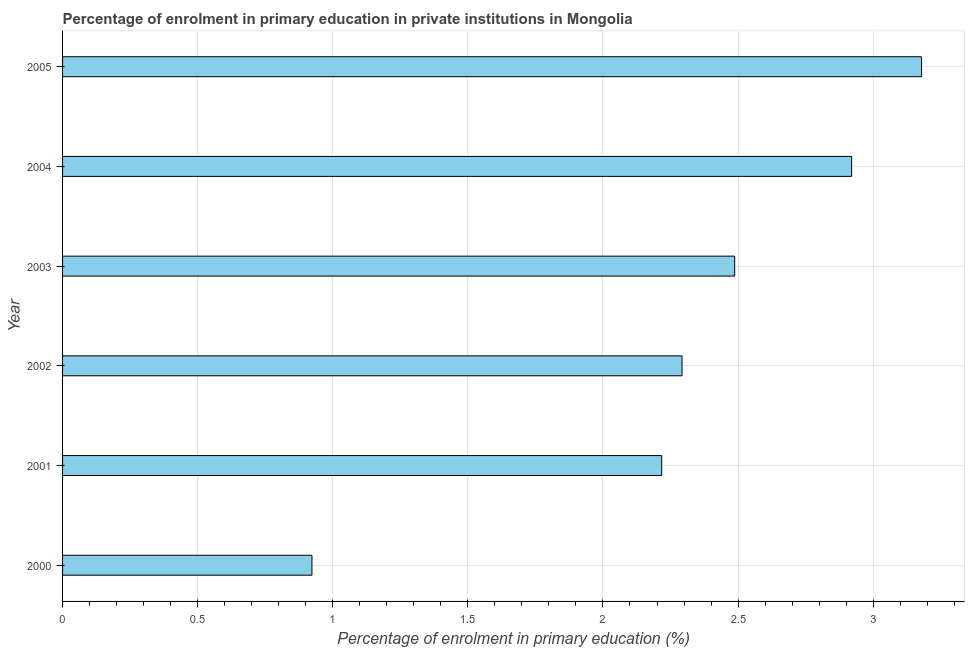Does the graph contain grids?
Offer a very short reply. Yes. What is the title of the graph?
Offer a very short reply. Percentage of enrolment in primary education in private institutions in Mongolia. What is the label or title of the X-axis?
Ensure brevity in your answer.  Percentage of enrolment in primary education (%). What is the enrolment percentage in primary education in 2003?
Provide a short and direct response. 2.49. Across all years, what is the maximum enrolment percentage in primary education?
Your response must be concise. 3.18. Across all years, what is the minimum enrolment percentage in primary education?
Ensure brevity in your answer.  0.92. In which year was the enrolment percentage in primary education maximum?
Offer a terse response. 2005. In which year was the enrolment percentage in primary education minimum?
Provide a succinct answer. 2000. What is the sum of the enrolment percentage in primary education?
Ensure brevity in your answer.  14.02. What is the difference between the enrolment percentage in primary education in 2001 and 2003?
Provide a succinct answer. -0.27. What is the average enrolment percentage in primary education per year?
Provide a short and direct response. 2.34. What is the median enrolment percentage in primary education?
Provide a succinct answer. 2.39. In how many years, is the enrolment percentage in primary education greater than 2.8 %?
Provide a short and direct response. 2. What is the ratio of the enrolment percentage in primary education in 2004 to that in 2005?
Offer a very short reply. 0.92. Is the enrolment percentage in primary education in 2000 less than that in 2003?
Provide a succinct answer. Yes. Is the difference between the enrolment percentage in primary education in 2000 and 2001 greater than the difference between any two years?
Make the answer very short. No. What is the difference between the highest and the second highest enrolment percentage in primary education?
Your answer should be very brief. 0.26. What is the difference between the highest and the lowest enrolment percentage in primary education?
Your answer should be compact. 2.26. In how many years, is the enrolment percentage in primary education greater than the average enrolment percentage in primary education taken over all years?
Keep it short and to the point. 3. Are all the bars in the graph horizontal?
Keep it short and to the point. Yes. How many years are there in the graph?
Give a very brief answer. 6. What is the Percentage of enrolment in primary education (%) in 2000?
Offer a very short reply. 0.92. What is the Percentage of enrolment in primary education (%) in 2001?
Provide a succinct answer. 2.22. What is the Percentage of enrolment in primary education (%) in 2002?
Offer a very short reply. 2.29. What is the Percentage of enrolment in primary education (%) in 2003?
Your answer should be very brief. 2.49. What is the Percentage of enrolment in primary education (%) in 2004?
Your response must be concise. 2.92. What is the Percentage of enrolment in primary education (%) of 2005?
Your response must be concise. 3.18. What is the difference between the Percentage of enrolment in primary education (%) in 2000 and 2001?
Keep it short and to the point. -1.29. What is the difference between the Percentage of enrolment in primary education (%) in 2000 and 2002?
Your response must be concise. -1.37. What is the difference between the Percentage of enrolment in primary education (%) in 2000 and 2003?
Your response must be concise. -1.56. What is the difference between the Percentage of enrolment in primary education (%) in 2000 and 2004?
Keep it short and to the point. -2. What is the difference between the Percentage of enrolment in primary education (%) in 2000 and 2005?
Provide a short and direct response. -2.26. What is the difference between the Percentage of enrolment in primary education (%) in 2001 and 2002?
Your answer should be compact. -0.08. What is the difference between the Percentage of enrolment in primary education (%) in 2001 and 2003?
Your response must be concise. -0.27. What is the difference between the Percentage of enrolment in primary education (%) in 2001 and 2004?
Give a very brief answer. -0.7. What is the difference between the Percentage of enrolment in primary education (%) in 2001 and 2005?
Your answer should be compact. -0.96. What is the difference between the Percentage of enrolment in primary education (%) in 2002 and 2003?
Make the answer very short. -0.19. What is the difference between the Percentage of enrolment in primary education (%) in 2002 and 2004?
Offer a very short reply. -0.63. What is the difference between the Percentage of enrolment in primary education (%) in 2002 and 2005?
Your answer should be compact. -0.89. What is the difference between the Percentage of enrolment in primary education (%) in 2003 and 2004?
Provide a short and direct response. -0.43. What is the difference between the Percentage of enrolment in primary education (%) in 2003 and 2005?
Keep it short and to the point. -0.69. What is the difference between the Percentage of enrolment in primary education (%) in 2004 and 2005?
Give a very brief answer. -0.26. What is the ratio of the Percentage of enrolment in primary education (%) in 2000 to that in 2001?
Provide a short and direct response. 0.42. What is the ratio of the Percentage of enrolment in primary education (%) in 2000 to that in 2002?
Offer a terse response. 0.4. What is the ratio of the Percentage of enrolment in primary education (%) in 2000 to that in 2003?
Your answer should be compact. 0.37. What is the ratio of the Percentage of enrolment in primary education (%) in 2000 to that in 2004?
Keep it short and to the point. 0.32. What is the ratio of the Percentage of enrolment in primary education (%) in 2000 to that in 2005?
Your response must be concise. 0.29. What is the ratio of the Percentage of enrolment in primary education (%) in 2001 to that in 2002?
Your answer should be very brief. 0.97. What is the ratio of the Percentage of enrolment in primary education (%) in 2001 to that in 2003?
Offer a terse response. 0.89. What is the ratio of the Percentage of enrolment in primary education (%) in 2001 to that in 2004?
Keep it short and to the point. 0.76. What is the ratio of the Percentage of enrolment in primary education (%) in 2001 to that in 2005?
Offer a very short reply. 0.7. What is the ratio of the Percentage of enrolment in primary education (%) in 2002 to that in 2003?
Ensure brevity in your answer.  0.92. What is the ratio of the Percentage of enrolment in primary education (%) in 2002 to that in 2004?
Your response must be concise. 0.79. What is the ratio of the Percentage of enrolment in primary education (%) in 2002 to that in 2005?
Keep it short and to the point. 0.72. What is the ratio of the Percentage of enrolment in primary education (%) in 2003 to that in 2004?
Provide a succinct answer. 0.85. What is the ratio of the Percentage of enrolment in primary education (%) in 2003 to that in 2005?
Provide a succinct answer. 0.78. What is the ratio of the Percentage of enrolment in primary education (%) in 2004 to that in 2005?
Keep it short and to the point. 0.92. 